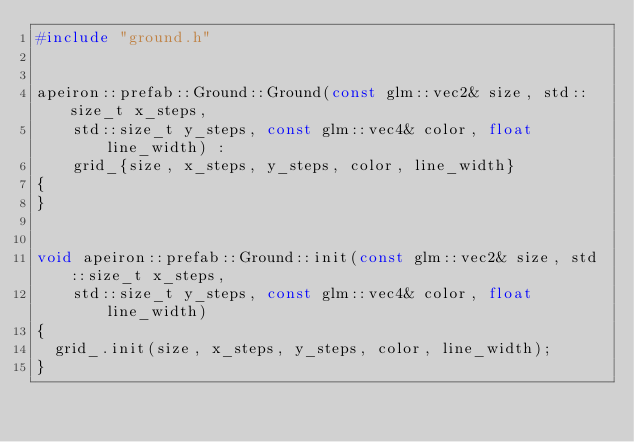<code> <loc_0><loc_0><loc_500><loc_500><_C++_>#include "ground.h"


apeiron::prefab::Ground::Ground(const glm::vec2& size, std::size_t x_steps,
    std::size_t y_steps, const glm::vec4& color, float line_width) :
    grid_{size, x_steps, y_steps, color, line_width}
{
}


void apeiron::prefab::Ground::init(const glm::vec2& size, std::size_t x_steps,
    std::size_t y_steps, const glm::vec4& color, float line_width)
{
  grid_.init(size, x_steps, y_steps, color, line_width);
}
</code> 